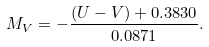Convert formula to latex. <formula><loc_0><loc_0><loc_500><loc_500>M _ { V } = - \frac { ( U - V ) + 0 . 3 8 3 0 } { 0 . 0 8 7 1 } .</formula> 